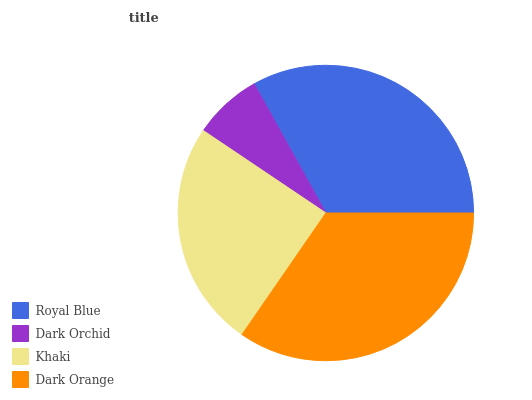Is Dark Orchid the minimum?
Answer yes or no. Yes. Is Dark Orange the maximum?
Answer yes or no. Yes. Is Khaki the minimum?
Answer yes or no. No. Is Khaki the maximum?
Answer yes or no. No. Is Khaki greater than Dark Orchid?
Answer yes or no. Yes. Is Dark Orchid less than Khaki?
Answer yes or no. Yes. Is Dark Orchid greater than Khaki?
Answer yes or no. No. Is Khaki less than Dark Orchid?
Answer yes or no. No. Is Royal Blue the high median?
Answer yes or no. Yes. Is Khaki the low median?
Answer yes or no. Yes. Is Dark Orange the high median?
Answer yes or no. No. Is Dark Orange the low median?
Answer yes or no. No. 